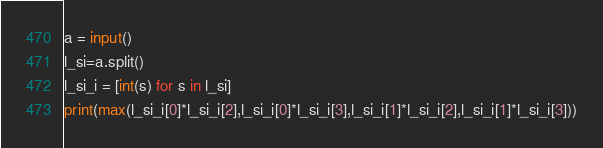Convert code to text. <code><loc_0><loc_0><loc_500><loc_500><_Python_>a = input()
l_si=a.split()
l_si_i = [int(s) for s in l_si]
print(max(l_si_i[0]*l_si_i[2],l_si_i[0]*l_si_i[3],l_si_i[1]*l_si_i[2],l_si_i[1]*l_si_i[3]))
</code> 